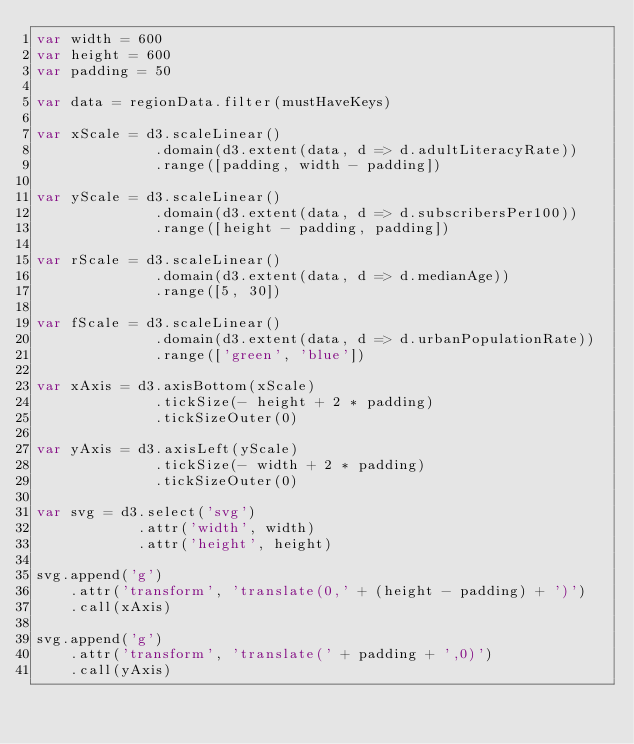Convert code to text. <code><loc_0><loc_0><loc_500><loc_500><_JavaScript_>var width = 600
var height = 600
var padding = 50

var data = regionData.filter(mustHaveKeys)

var xScale = d3.scaleLinear()
              .domain(d3.extent(data, d => d.adultLiteracyRate))
              .range([padding, width - padding])

var yScale = d3.scaleLinear()
              .domain(d3.extent(data, d => d.subscribersPer100))
              .range([height - padding, padding])

var rScale = d3.scaleLinear()
              .domain(d3.extent(data, d => d.medianAge))
              .range([5, 30])

var fScale = d3.scaleLinear()
              .domain(d3.extent(data, d => d.urbanPopulationRate))
              .range(['green', 'blue'])

var xAxis = d3.axisBottom(xScale)
              .tickSize(- height + 2 * padding)
              .tickSizeOuter(0)

var yAxis = d3.axisLeft(yScale)
              .tickSize(- width + 2 * padding)
              .tickSizeOuter(0)

var svg = d3.select('svg')
            .attr('width', width)
            .attr('height', height)

svg.append('g')
    .attr('transform', 'translate(0,' + (height - padding) + ')')
    .call(xAxis)

svg.append('g')
    .attr('transform', 'translate(' + padding + ',0)')
    .call(yAxis)
</code> 